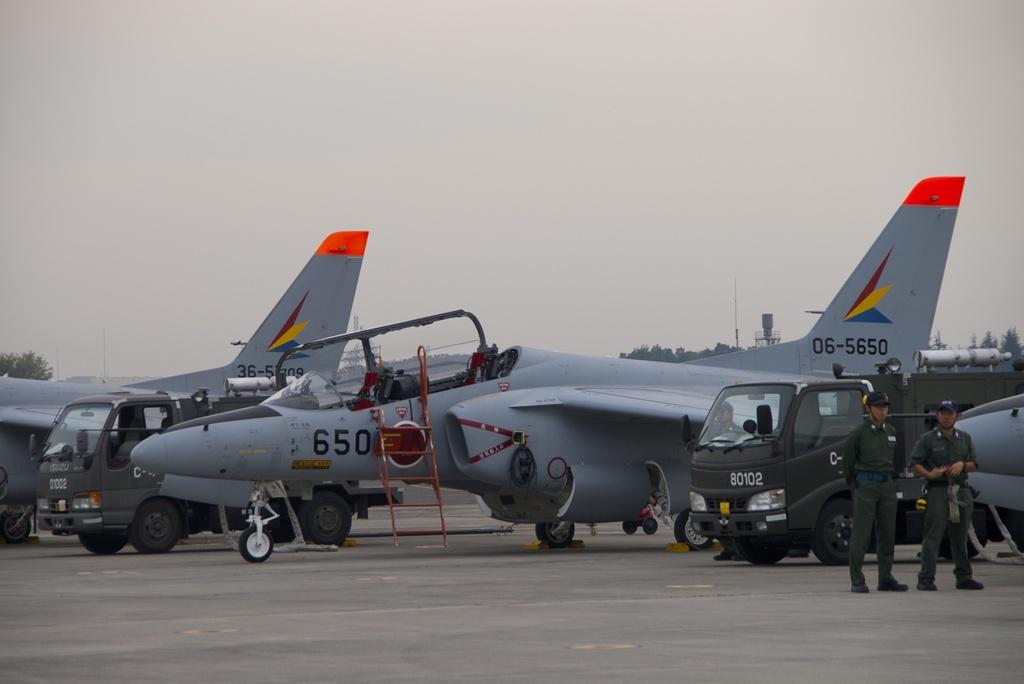What can be seen on the road in the image? There are vehicles and aeroplanes on the road in the image. Who is present near the vehicles and aeroplanes? There are two persons standing beside the vehicles and aeroplanes. What is visible at the back side of the image? There are trees and a water tank visible at the back side of the image. What is visible at the top of the image? The sky is visible at the top of the image. What is the average income of the vehicles in the image? Vehicles do not have an income, as they are inanimate objects. Can you touch the clocks in the image? There are no clocks present in the image. 